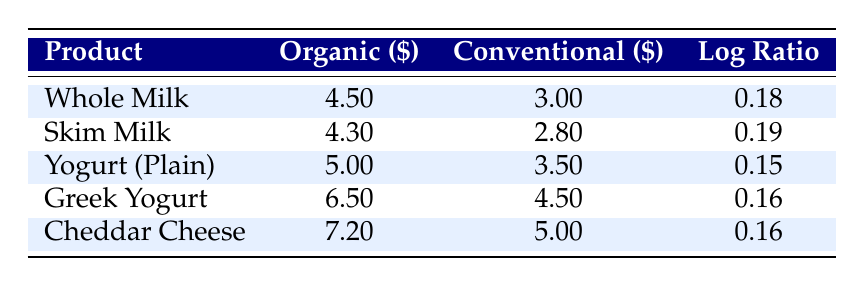What is the price of Organic Whole Milk? The table lists the price for Organic Whole Milk in the "Organic" column, which states it is 4.50 USD.
Answer: 4.50 USD What is the price difference between Organic Skim Milk and Conventional Skim Milk? From the table, Organic Skim Milk costs 4.30 USD and Conventional Skim Milk costs 2.80 USD. The difference is calculated as 4.30 - 2.80 = 1.50 USD.
Answer: 1.50 USD Is Organic Greek Yogurt more expensive than Conventional Greek Yogurt? The table shows Organic Greek Yogurt at 6.50 USD and Conventional Greek Yogurt at 4.50 USD. Since 6.50 is greater than 4.50, it is indeed more expensive.
Answer: Yes What is the average price of all the organic dairy products listed? The prices for organic products are 4.50, 4.30, 5.00, 6.50, and 7.20 USD. Summing these gives 4.50 + 4.30 + 5.00 + 6.50 + 7.20 = 27.50 USD. There are 5 products, so the average is 27.50 / 5 = 5.50 USD.
Answer: 5.50 USD Which organic product has the highest price? Looking at the "Organic" column, the values are 4.50, 4.30, 5.00, 6.50, and 7.20 USD. The highest among these is 7.20 USD for Organic Cheddar Cheese.
Answer: Organic Cheddar Cheese How much more expensive is Organic Yogurt than Conventional Yogurt? Organic Yogurt costs 5.00 USD and Conventional Yogurt costs 3.50 USD. To find the difference, subtract 3.50 from 5.00, which results in 1.50 USD.
Answer: 1.50 USD Is the price ratio of Organic Cheddar Cheese to Conventional Cheddar Cheese greater than 1? The price of Organic Cheddar Cheese is 7.20 USD and Conventional Cheddar Cheese is 5.00 USD. The ratio is 7.20 / 5.00 = 1.44, which is greater than 1.
Answer: Yes What is the total monthly cost of all organic dairy products? Summing the prices of all organic products: 4.50 + 4.30 + 5.00 + 6.50 + 7.20 = 27.50 USD.
Answer: 27.50 USD Which conventional dairy product is the least expensive? The table lists the prices as 3.00, 2.80, 3.50, 4.50, and 5.00 USD. The lowest value is 2.80 USD for Conventional Skim Milk.
Answer: Conventional Skim Milk 